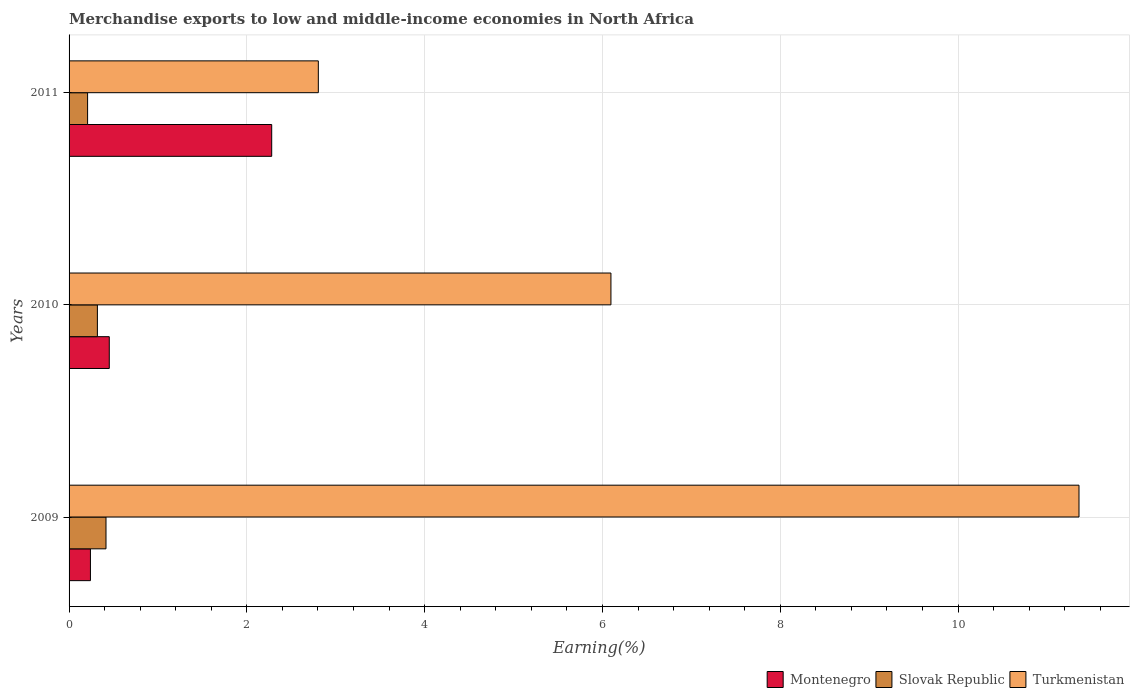How many groups of bars are there?
Your answer should be compact. 3. Are the number of bars per tick equal to the number of legend labels?
Your answer should be compact. Yes. Are the number of bars on each tick of the Y-axis equal?
Keep it short and to the point. Yes. How many bars are there on the 3rd tick from the bottom?
Give a very brief answer. 3. In how many cases, is the number of bars for a given year not equal to the number of legend labels?
Your answer should be very brief. 0. What is the percentage of amount earned from merchandise exports in Slovak Republic in 2011?
Keep it short and to the point. 0.21. Across all years, what is the maximum percentage of amount earned from merchandise exports in Montenegro?
Your answer should be compact. 2.28. Across all years, what is the minimum percentage of amount earned from merchandise exports in Turkmenistan?
Ensure brevity in your answer.  2.8. In which year was the percentage of amount earned from merchandise exports in Slovak Republic minimum?
Your answer should be compact. 2011. What is the total percentage of amount earned from merchandise exports in Turkmenistan in the graph?
Keep it short and to the point. 20.26. What is the difference between the percentage of amount earned from merchandise exports in Montenegro in 2009 and that in 2010?
Your answer should be compact. -0.21. What is the difference between the percentage of amount earned from merchandise exports in Montenegro in 2009 and the percentage of amount earned from merchandise exports in Turkmenistan in 2011?
Give a very brief answer. -2.56. What is the average percentage of amount earned from merchandise exports in Turkmenistan per year?
Make the answer very short. 6.75. In the year 2011, what is the difference between the percentage of amount earned from merchandise exports in Turkmenistan and percentage of amount earned from merchandise exports in Montenegro?
Provide a succinct answer. 0.52. In how many years, is the percentage of amount earned from merchandise exports in Turkmenistan greater than 9.2 %?
Offer a very short reply. 1. What is the ratio of the percentage of amount earned from merchandise exports in Slovak Republic in 2009 to that in 2011?
Give a very brief answer. 1.99. What is the difference between the highest and the second highest percentage of amount earned from merchandise exports in Slovak Republic?
Offer a very short reply. 0.1. What is the difference between the highest and the lowest percentage of amount earned from merchandise exports in Slovak Republic?
Offer a terse response. 0.21. Is the sum of the percentage of amount earned from merchandise exports in Montenegro in 2009 and 2011 greater than the maximum percentage of amount earned from merchandise exports in Turkmenistan across all years?
Offer a very short reply. No. What does the 1st bar from the top in 2010 represents?
Provide a short and direct response. Turkmenistan. What does the 3rd bar from the bottom in 2011 represents?
Offer a terse response. Turkmenistan. Is it the case that in every year, the sum of the percentage of amount earned from merchandise exports in Montenegro and percentage of amount earned from merchandise exports in Slovak Republic is greater than the percentage of amount earned from merchandise exports in Turkmenistan?
Make the answer very short. No. How many bars are there?
Offer a terse response. 9. What is the difference between two consecutive major ticks on the X-axis?
Offer a terse response. 2. Are the values on the major ticks of X-axis written in scientific E-notation?
Offer a very short reply. No. Where does the legend appear in the graph?
Provide a succinct answer. Bottom right. How are the legend labels stacked?
Your answer should be very brief. Horizontal. What is the title of the graph?
Ensure brevity in your answer.  Merchandise exports to low and middle-income economies in North Africa. Does "Isle of Man" appear as one of the legend labels in the graph?
Your answer should be compact. No. What is the label or title of the X-axis?
Ensure brevity in your answer.  Earning(%). What is the Earning(%) of Montenegro in 2009?
Offer a very short reply. 0.24. What is the Earning(%) of Slovak Republic in 2009?
Provide a short and direct response. 0.42. What is the Earning(%) in Turkmenistan in 2009?
Keep it short and to the point. 11.36. What is the Earning(%) in Montenegro in 2010?
Provide a succinct answer. 0.45. What is the Earning(%) in Slovak Republic in 2010?
Your response must be concise. 0.32. What is the Earning(%) in Turkmenistan in 2010?
Keep it short and to the point. 6.1. What is the Earning(%) in Montenegro in 2011?
Provide a succinct answer. 2.28. What is the Earning(%) in Slovak Republic in 2011?
Offer a very short reply. 0.21. What is the Earning(%) in Turkmenistan in 2011?
Keep it short and to the point. 2.8. Across all years, what is the maximum Earning(%) of Montenegro?
Provide a succinct answer. 2.28. Across all years, what is the maximum Earning(%) in Slovak Republic?
Your response must be concise. 0.42. Across all years, what is the maximum Earning(%) in Turkmenistan?
Offer a very short reply. 11.36. Across all years, what is the minimum Earning(%) in Montenegro?
Keep it short and to the point. 0.24. Across all years, what is the minimum Earning(%) in Slovak Republic?
Give a very brief answer. 0.21. Across all years, what is the minimum Earning(%) of Turkmenistan?
Your response must be concise. 2.8. What is the total Earning(%) of Montenegro in the graph?
Keep it short and to the point. 2.97. What is the total Earning(%) of Slovak Republic in the graph?
Provide a short and direct response. 0.94. What is the total Earning(%) in Turkmenistan in the graph?
Offer a terse response. 20.26. What is the difference between the Earning(%) in Montenegro in 2009 and that in 2010?
Ensure brevity in your answer.  -0.21. What is the difference between the Earning(%) in Slovak Republic in 2009 and that in 2010?
Provide a short and direct response. 0.1. What is the difference between the Earning(%) in Turkmenistan in 2009 and that in 2010?
Give a very brief answer. 5.27. What is the difference between the Earning(%) in Montenegro in 2009 and that in 2011?
Provide a succinct answer. -2.04. What is the difference between the Earning(%) in Slovak Republic in 2009 and that in 2011?
Provide a short and direct response. 0.21. What is the difference between the Earning(%) of Turkmenistan in 2009 and that in 2011?
Give a very brief answer. 8.56. What is the difference between the Earning(%) in Montenegro in 2010 and that in 2011?
Provide a short and direct response. -1.83. What is the difference between the Earning(%) of Slovak Republic in 2010 and that in 2011?
Give a very brief answer. 0.11. What is the difference between the Earning(%) in Turkmenistan in 2010 and that in 2011?
Provide a short and direct response. 3.29. What is the difference between the Earning(%) of Montenegro in 2009 and the Earning(%) of Slovak Republic in 2010?
Make the answer very short. -0.08. What is the difference between the Earning(%) of Montenegro in 2009 and the Earning(%) of Turkmenistan in 2010?
Offer a very short reply. -5.86. What is the difference between the Earning(%) of Slovak Republic in 2009 and the Earning(%) of Turkmenistan in 2010?
Offer a very short reply. -5.68. What is the difference between the Earning(%) in Montenegro in 2009 and the Earning(%) in Slovak Republic in 2011?
Make the answer very short. 0.03. What is the difference between the Earning(%) in Montenegro in 2009 and the Earning(%) in Turkmenistan in 2011?
Your answer should be compact. -2.56. What is the difference between the Earning(%) of Slovak Republic in 2009 and the Earning(%) of Turkmenistan in 2011?
Your answer should be very brief. -2.39. What is the difference between the Earning(%) of Montenegro in 2010 and the Earning(%) of Slovak Republic in 2011?
Your answer should be compact. 0.24. What is the difference between the Earning(%) of Montenegro in 2010 and the Earning(%) of Turkmenistan in 2011?
Your answer should be compact. -2.35. What is the difference between the Earning(%) in Slovak Republic in 2010 and the Earning(%) in Turkmenistan in 2011?
Keep it short and to the point. -2.49. What is the average Earning(%) in Montenegro per year?
Your response must be concise. 0.99. What is the average Earning(%) of Slovak Republic per year?
Give a very brief answer. 0.31. What is the average Earning(%) of Turkmenistan per year?
Ensure brevity in your answer.  6.75. In the year 2009, what is the difference between the Earning(%) in Montenegro and Earning(%) in Slovak Republic?
Your answer should be very brief. -0.18. In the year 2009, what is the difference between the Earning(%) in Montenegro and Earning(%) in Turkmenistan?
Your response must be concise. -11.12. In the year 2009, what is the difference between the Earning(%) in Slovak Republic and Earning(%) in Turkmenistan?
Ensure brevity in your answer.  -10.95. In the year 2010, what is the difference between the Earning(%) in Montenegro and Earning(%) in Slovak Republic?
Provide a short and direct response. 0.13. In the year 2010, what is the difference between the Earning(%) in Montenegro and Earning(%) in Turkmenistan?
Ensure brevity in your answer.  -5.64. In the year 2010, what is the difference between the Earning(%) of Slovak Republic and Earning(%) of Turkmenistan?
Make the answer very short. -5.78. In the year 2011, what is the difference between the Earning(%) in Montenegro and Earning(%) in Slovak Republic?
Your answer should be compact. 2.07. In the year 2011, what is the difference between the Earning(%) in Montenegro and Earning(%) in Turkmenistan?
Your response must be concise. -0.52. In the year 2011, what is the difference between the Earning(%) in Slovak Republic and Earning(%) in Turkmenistan?
Your answer should be very brief. -2.6. What is the ratio of the Earning(%) of Montenegro in 2009 to that in 2010?
Provide a short and direct response. 0.53. What is the ratio of the Earning(%) in Slovak Republic in 2009 to that in 2010?
Make the answer very short. 1.3. What is the ratio of the Earning(%) in Turkmenistan in 2009 to that in 2010?
Give a very brief answer. 1.86. What is the ratio of the Earning(%) of Montenegro in 2009 to that in 2011?
Offer a very short reply. 0.11. What is the ratio of the Earning(%) in Slovak Republic in 2009 to that in 2011?
Your response must be concise. 1.99. What is the ratio of the Earning(%) in Turkmenistan in 2009 to that in 2011?
Your answer should be very brief. 4.05. What is the ratio of the Earning(%) of Montenegro in 2010 to that in 2011?
Provide a short and direct response. 0.2. What is the ratio of the Earning(%) in Slovak Republic in 2010 to that in 2011?
Give a very brief answer. 1.53. What is the ratio of the Earning(%) of Turkmenistan in 2010 to that in 2011?
Provide a short and direct response. 2.17. What is the difference between the highest and the second highest Earning(%) of Montenegro?
Provide a short and direct response. 1.83. What is the difference between the highest and the second highest Earning(%) of Slovak Republic?
Ensure brevity in your answer.  0.1. What is the difference between the highest and the second highest Earning(%) in Turkmenistan?
Offer a terse response. 5.27. What is the difference between the highest and the lowest Earning(%) in Montenegro?
Make the answer very short. 2.04. What is the difference between the highest and the lowest Earning(%) of Slovak Republic?
Your answer should be compact. 0.21. What is the difference between the highest and the lowest Earning(%) of Turkmenistan?
Provide a short and direct response. 8.56. 